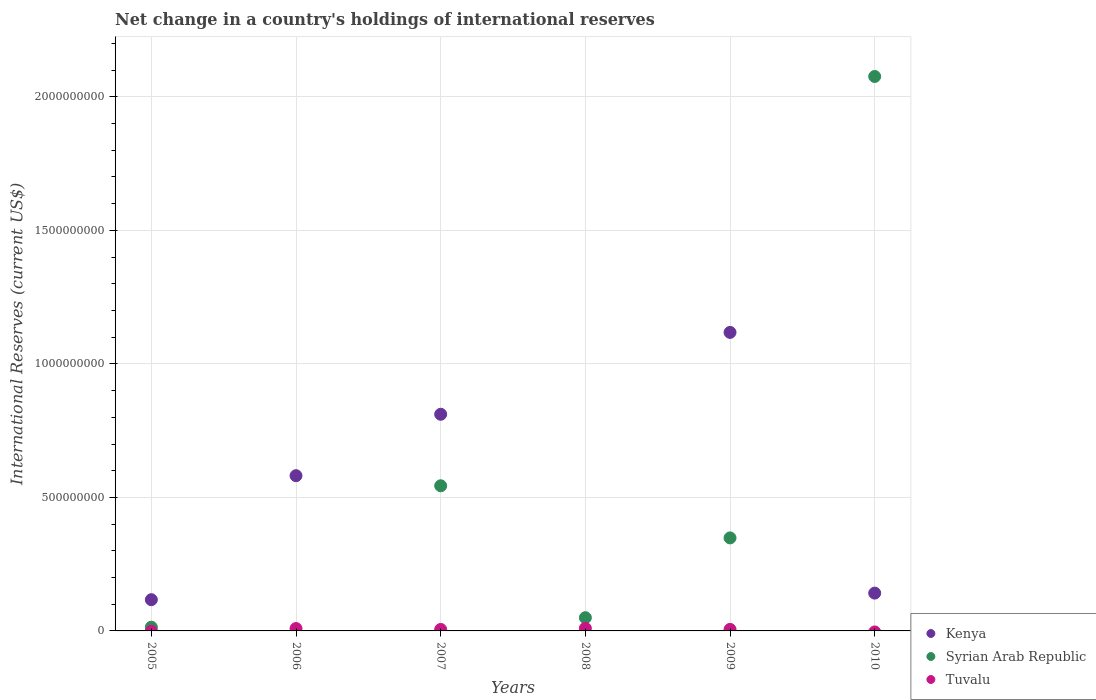Is the number of dotlines equal to the number of legend labels?
Provide a succinct answer. No. What is the international reserves in Syrian Arab Republic in 2010?
Keep it short and to the point. 2.08e+09. Across all years, what is the maximum international reserves in Kenya?
Make the answer very short. 1.12e+09. Across all years, what is the minimum international reserves in Syrian Arab Republic?
Your answer should be compact. 0. In which year was the international reserves in Kenya maximum?
Your answer should be compact. 2009. What is the total international reserves in Tuvalu in the graph?
Your response must be concise. 3.00e+07. What is the difference between the international reserves in Syrian Arab Republic in 2007 and that in 2009?
Offer a terse response. 1.95e+08. What is the difference between the international reserves in Syrian Arab Republic in 2005 and the international reserves in Kenya in 2009?
Provide a short and direct response. -1.10e+09. What is the average international reserves in Tuvalu per year?
Give a very brief answer. 5.00e+06. In the year 2005, what is the difference between the international reserves in Kenya and international reserves in Syrian Arab Republic?
Offer a terse response. 1.03e+08. What is the ratio of the international reserves in Kenya in 2009 to that in 2010?
Make the answer very short. 7.9. What is the difference between the highest and the second highest international reserves in Kenya?
Give a very brief answer. 3.07e+08. What is the difference between the highest and the lowest international reserves in Syrian Arab Republic?
Provide a short and direct response. 2.08e+09. In how many years, is the international reserves in Syrian Arab Republic greater than the average international reserves in Syrian Arab Republic taken over all years?
Keep it short and to the point. 2. Does the international reserves in Tuvalu monotonically increase over the years?
Provide a short and direct response. No. Is the international reserves in Syrian Arab Republic strictly less than the international reserves in Kenya over the years?
Offer a very short reply. No. Are the values on the major ticks of Y-axis written in scientific E-notation?
Provide a short and direct response. No. Does the graph contain any zero values?
Give a very brief answer. Yes. Does the graph contain grids?
Provide a short and direct response. Yes. Where does the legend appear in the graph?
Offer a very short reply. Bottom right. How are the legend labels stacked?
Provide a succinct answer. Vertical. What is the title of the graph?
Provide a succinct answer. Net change in a country's holdings of international reserves. What is the label or title of the X-axis?
Give a very brief answer. Years. What is the label or title of the Y-axis?
Provide a short and direct response. International Reserves (current US$). What is the International Reserves (current US$) in Kenya in 2005?
Your answer should be compact. 1.17e+08. What is the International Reserves (current US$) in Syrian Arab Republic in 2005?
Your answer should be very brief. 1.40e+07. What is the International Reserves (current US$) in Tuvalu in 2005?
Provide a succinct answer. 0. What is the International Reserves (current US$) of Kenya in 2006?
Offer a very short reply. 5.81e+08. What is the International Reserves (current US$) in Syrian Arab Republic in 2006?
Provide a succinct answer. 0. What is the International Reserves (current US$) of Tuvalu in 2006?
Your response must be concise. 8.93e+06. What is the International Reserves (current US$) in Kenya in 2007?
Your answer should be compact. 8.11e+08. What is the International Reserves (current US$) of Syrian Arab Republic in 2007?
Provide a succinct answer. 5.44e+08. What is the International Reserves (current US$) in Tuvalu in 2007?
Ensure brevity in your answer.  5.58e+06. What is the International Reserves (current US$) in Kenya in 2008?
Provide a short and direct response. 0. What is the International Reserves (current US$) of Syrian Arab Republic in 2008?
Provide a succinct answer. 4.96e+07. What is the International Reserves (current US$) in Tuvalu in 2008?
Provide a short and direct response. 9.75e+06. What is the International Reserves (current US$) of Kenya in 2009?
Give a very brief answer. 1.12e+09. What is the International Reserves (current US$) in Syrian Arab Republic in 2009?
Your response must be concise. 3.48e+08. What is the International Reserves (current US$) of Tuvalu in 2009?
Ensure brevity in your answer.  5.74e+06. What is the International Reserves (current US$) in Kenya in 2010?
Your answer should be compact. 1.42e+08. What is the International Reserves (current US$) in Syrian Arab Republic in 2010?
Offer a very short reply. 2.08e+09. Across all years, what is the maximum International Reserves (current US$) in Kenya?
Offer a very short reply. 1.12e+09. Across all years, what is the maximum International Reserves (current US$) of Syrian Arab Republic?
Provide a short and direct response. 2.08e+09. Across all years, what is the maximum International Reserves (current US$) of Tuvalu?
Your answer should be very brief. 9.75e+06. Across all years, what is the minimum International Reserves (current US$) of Syrian Arab Republic?
Ensure brevity in your answer.  0. Across all years, what is the minimum International Reserves (current US$) in Tuvalu?
Your answer should be compact. 0. What is the total International Reserves (current US$) of Kenya in the graph?
Offer a terse response. 2.77e+09. What is the total International Reserves (current US$) in Syrian Arab Republic in the graph?
Ensure brevity in your answer.  3.03e+09. What is the total International Reserves (current US$) in Tuvalu in the graph?
Provide a short and direct response. 3.00e+07. What is the difference between the International Reserves (current US$) in Kenya in 2005 and that in 2006?
Provide a short and direct response. -4.64e+08. What is the difference between the International Reserves (current US$) in Kenya in 2005 and that in 2007?
Make the answer very short. -6.94e+08. What is the difference between the International Reserves (current US$) of Syrian Arab Republic in 2005 and that in 2007?
Make the answer very short. -5.30e+08. What is the difference between the International Reserves (current US$) of Syrian Arab Republic in 2005 and that in 2008?
Make the answer very short. -3.56e+07. What is the difference between the International Reserves (current US$) in Kenya in 2005 and that in 2009?
Keep it short and to the point. -1.00e+09. What is the difference between the International Reserves (current US$) in Syrian Arab Republic in 2005 and that in 2009?
Provide a short and direct response. -3.34e+08. What is the difference between the International Reserves (current US$) in Kenya in 2005 and that in 2010?
Your answer should be compact. -2.46e+07. What is the difference between the International Reserves (current US$) in Syrian Arab Republic in 2005 and that in 2010?
Provide a short and direct response. -2.06e+09. What is the difference between the International Reserves (current US$) in Kenya in 2006 and that in 2007?
Give a very brief answer. -2.30e+08. What is the difference between the International Reserves (current US$) in Tuvalu in 2006 and that in 2007?
Provide a succinct answer. 3.34e+06. What is the difference between the International Reserves (current US$) of Tuvalu in 2006 and that in 2008?
Your answer should be compact. -8.27e+05. What is the difference between the International Reserves (current US$) of Kenya in 2006 and that in 2009?
Your response must be concise. -5.37e+08. What is the difference between the International Reserves (current US$) in Tuvalu in 2006 and that in 2009?
Make the answer very short. 3.19e+06. What is the difference between the International Reserves (current US$) in Kenya in 2006 and that in 2010?
Provide a short and direct response. 4.40e+08. What is the difference between the International Reserves (current US$) of Syrian Arab Republic in 2007 and that in 2008?
Your answer should be compact. 4.94e+08. What is the difference between the International Reserves (current US$) of Tuvalu in 2007 and that in 2008?
Offer a terse response. -4.17e+06. What is the difference between the International Reserves (current US$) of Kenya in 2007 and that in 2009?
Provide a short and direct response. -3.07e+08. What is the difference between the International Reserves (current US$) in Syrian Arab Republic in 2007 and that in 2009?
Your answer should be compact. 1.95e+08. What is the difference between the International Reserves (current US$) in Tuvalu in 2007 and that in 2009?
Offer a very short reply. -1.52e+05. What is the difference between the International Reserves (current US$) in Kenya in 2007 and that in 2010?
Provide a short and direct response. 6.70e+08. What is the difference between the International Reserves (current US$) of Syrian Arab Republic in 2007 and that in 2010?
Provide a succinct answer. -1.53e+09. What is the difference between the International Reserves (current US$) of Syrian Arab Republic in 2008 and that in 2009?
Offer a very short reply. -2.99e+08. What is the difference between the International Reserves (current US$) in Tuvalu in 2008 and that in 2009?
Offer a terse response. 4.02e+06. What is the difference between the International Reserves (current US$) of Syrian Arab Republic in 2008 and that in 2010?
Provide a short and direct response. -2.03e+09. What is the difference between the International Reserves (current US$) of Kenya in 2009 and that in 2010?
Offer a terse response. 9.76e+08. What is the difference between the International Reserves (current US$) of Syrian Arab Republic in 2009 and that in 2010?
Offer a very short reply. -1.73e+09. What is the difference between the International Reserves (current US$) in Kenya in 2005 and the International Reserves (current US$) in Tuvalu in 2006?
Offer a very short reply. 1.08e+08. What is the difference between the International Reserves (current US$) of Syrian Arab Republic in 2005 and the International Reserves (current US$) of Tuvalu in 2006?
Give a very brief answer. 5.07e+06. What is the difference between the International Reserves (current US$) of Kenya in 2005 and the International Reserves (current US$) of Syrian Arab Republic in 2007?
Make the answer very short. -4.27e+08. What is the difference between the International Reserves (current US$) in Kenya in 2005 and the International Reserves (current US$) in Tuvalu in 2007?
Ensure brevity in your answer.  1.11e+08. What is the difference between the International Reserves (current US$) of Syrian Arab Republic in 2005 and the International Reserves (current US$) of Tuvalu in 2007?
Offer a terse response. 8.41e+06. What is the difference between the International Reserves (current US$) of Kenya in 2005 and the International Reserves (current US$) of Syrian Arab Republic in 2008?
Your answer should be very brief. 6.74e+07. What is the difference between the International Reserves (current US$) in Kenya in 2005 and the International Reserves (current US$) in Tuvalu in 2008?
Offer a very short reply. 1.07e+08. What is the difference between the International Reserves (current US$) in Syrian Arab Republic in 2005 and the International Reserves (current US$) in Tuvalu in 2008?
Provide a short and direct response. 4.24e+06. What is the difference between the International Reserves (current US$) in Kenya in 2005 and the International Reserves (current US$) in Syrian Arab Republic in 2009?
Your answer should be very brief. -2.31e+08. What is the difference between the International Reserves (current US$) of Kenya in 2005 and the International Reserves (current US$) of Tuvalu in 2009?
Your answer should be compact. 1.11e+08. What is the difference between the International Reserves (current US$) of Syrian Arab Republic in 2005 and the International Reserves (current US$) of Tuvalu in 2009?
Provide a short and direct response. 8.26e+06. What is the difference between the International Reserves (current US$) of Kenya in 2005 and the International Reserves (current US$) of Syrian Arab Republic in 2010?
Give a very brief answer. -1.96e+09. What is the difference between the International Reserves (current US$) in Kenya in 2006 and the International Reserves (current US$) in Syrian Arab Republic in 2007?
Ensure brevity in your answer.  3.78e+07. What is the difference between the International Reserves (current US$) in Kenya in 2006 and the International Reserves (current US$) in Tuvalu in 2007?
Make the answer very short. 5.76e+08. What is the difference between the International Reserves (current US$) in Kenya in 2006 and the International Reserves (current US$) in Syrian Arab Republic in 2008?
Your answer should be compact. 5.32e+08. What is the difference between the International Reserves (current US$) of Kenya in 2006 and the International Reserves (current US$) of Tuvalu in 2008?
Offer a terse response. 5.72e+08. What is the difference between the International Reserves (current US$) in Kenya in 2006 and the International Reserves (current US$) in Syrian Arab Republic in 2009?
Make the answer very short. 2.33e+08. What is the difference between the International Reserves (current US$) of Kenya in 2006 and the International Reserves (current US$) of Tuvalu in 2009?
Keep it short and to the point. 5.76e+08. What is the difference between the International Reserves (current US$) in Kenya in 2006 and the International Reserves (current US$) in Syrian Arab Republic in 2010?
Provide a succinct answer. -1.50e+09. What is the difference between the International Reserves (current US$) of Kenya in 2007 and the International Reserves (current US$) of Syrian Arab Republic in 2008?
Offer a terse response. 7.62e+08. What is the difference between the International Reserves (current US$) of Kenya in 2007 and the International Reserves (current US$) of Tuvalu in 2008?
Provide a succinct answer. 8.02e+08. What is the difference between the International Reserves (current US$) of Syrian Arab Republic in 2007 and the International Reserves (current US$) of Tuvalu in 2008?
Your answer should be very brief. 5.34e+08. What is the difference between the International Reserves (current US$) in Kenya in 2007 and the International Reserves (current US$) in Syrian Arab Republic in 2009?
Ensure brevity in your answer.  4.63e+08. What is the difference between the International Reserves (current US$) of Kenya in 2007 and the International Reserves (current US$) of Tuvalu in 2009?
Offer a terse response. 8.06e+08. What is the difference between the International Reserves (current US$) in Syrian Arab Republic in 2007 and the International Reserves (current US$) in Tuvalu in 2009?
Provide a short and direct response. 5.38e+08. What is the difference between the International Reserves (current US$) of Kenya in 2007 and the International Reserves (current US$) of Syrian Arab Republic in 2010?
Your answer should be very brief. -1.27e+09. What is the difference between the International Reserves (current US$) of Syrian Arab Republic in 2008 and the International Reserves (current US$) of Tuvalu in 2009?
Give a very brief answer. 4.38e+07. What is the difference between the International Reserves (current US$) in Kenya in 2009 and the International Reserves (current US$) in Syrian Arab Republic in 2010?
Give a very brief answer. -9.58e+08. What is the average International Reserves (current US$) in Kenya per year?
Keep it short and to the point. 4.62e+08. What is the average International Reserves (current US$) of Syrian Arab Republic per year?
Provide a succinct answer. 5.05e+08. What is the average International Reserves (current US$) in Tuvalu per year?
Give a very brief answer. 5.00e+06. In the year 2005, what is the difference between the International Reserves (current US$) in Kenya and International Reserves (current US$) in Syrian Arab Republic?
Keep it short and to the point. 1.03e+08. In the year 2006, what is the difference between the International Reserves (current US$) in Kenya and International Reserves (current US$) in Tuvalu?
Provide a succinct answer. 5.72e+08. In the year 2007, what is the difference between the International Reserves (current US$) in Kenya and International Reserves (current US$) in Syrian Arab Republic?
Provide a short and direct response. 2.68e+08. In the year 2007, what is the difference between the International Reserves (current US$) in Kenya and International Reserves (current US$) in Tuvalu?
Your answer should be very brief. 8.06e+08. In the year 2007, what is the difference between the International Reserves (current US$) in Syrian Arab Republic and International Reserves (current US$) in Tuvalu?
Ensure brevity in your answer.  5.38e+08. In the year 2008, what is the difference between the International Reserves (current US$) in Syrian Arab Republic and International Reserves (current US$) in Tuvalu?
Provide a succinct answer. 3.98e+07. In the year 2009, what is the difference between the International Reserves (current US$) of Kenya and International Reserves (current US$) of Syrian Arab Republic?
Offer a very short reply. 7.70e+08. In the year 2009, what is the difference between the International Reserves (current US$) of Kenya and International Reserves (current US$) of Tuvalu?
Provide a short and direct response. 1.11e+09. In the year 2009, what is the difference between the International Reserves (current US$) of Syrian Arab Republic and International Reserves (current US$) of Tuvalu?
Ensure brevity in your answer.  3.43e+08. In the year 2010, what is the difference between the International Reserves (current US$) in Kenya and International Reserves (current US$) in Syrian Arab Republic?
Your answer should be very brief. -1.93e+09. What is the ratio of the International Reserves (current US$) of Kenya in 2005 to that in 2006?
Your answer should be very brief. 0.2. What is the ratio of the International Reserves (current US$) of Kenya in 2005 to that in 2007?
Make the answer very short. 0.14. What is the ratio of the International Reserves (current US$) in Syrian Arab Republic in 2005 to that in 2007?
Your response must be concise. 0.03. What is the ratio of the International Reserves (current US$) in Syrian Arab Republic in 2005 to that in 2008?
Give a very brief answer. 0.28. What is the ratio of the International Reserves (current US$) in Kenya in 2005 to that in 2009?
Make the answer very short. 0.1. What is the ratio of the International Reserves (current US$) of Syrian Arab Republic in 2005 to that in 2009?
Your answer should be compact. 0.04. What is the ratio of the International Reserves (current US$) in Kenya in 2005 to that in 2010?
Your answer should be very brief. 0.83. What is the ratio of the International Reserves (current US$) of Syrian Arab Republic in 2005 to that in 2010?
Make the answer very short. 0.01. What is the ratio of the International Reserves (current US$) of Kenya in 2006 to that in 2007?
Make the answer very short. 0.72. What is the ratio of the International Reserves (current US$) of Tuvalu in 2006 to that in 2007?
Your response must be concise. 1.6. What is the ratio of the International Reserves (current US$) in Tuvalu in 2006 to that in 2008?
Your answer should be very brief. 0.92. What is the ratio of the International Reserves (current US$) of Kenya in 2006 to that in 2009?
Your answer should be very brief. 0.52. What is the ratio of the International Reserves (current US$) of Tuvalu in 2006 to that in 2009?
Provide a short and direct response. 1.56. What is the ratio of the International Reserves (current US$) in Kenya in 2006 to that in 2010?
Provide a succinct answer. 4.11. What is the ratio of the International Reserves (current US$) in Syrian Arab Republic in 2007 to that in 2008?
Give a very brief answer. 10.97. What is the ratio of the International Reserves (current US$) of Tuvalu in 2007 to that in 2008?
Offer a terse response. 0.57. What is the ratio of the International Reserves (current US$) of Kenya in 2007 to that in 2009?
Provide a short and direct response. 0.73. What is the ratio of the International Reserves (current US$) in Syrian Arab Republic in 2007 to that in 2009?
Your response must be concise. 1.56. What is the ratio of the International Reserves (current US$) in Tuvalu in 2007 to that in 2009?
Provide a succinct answer. 0.97. What is the ratio of the International Reserves (current US$) of Kenya in 2007 to that in 2010?
Provide a short and direct response. 5.73. What is the ratio of the International Reserves (current US$) of Syrian Arab Republic in 2007 to that in 2010?
Offer a terse response. 0.26. What is the ratio of the International Reserves (current US$) of Syrian Arab Republic in 2008 to that in 2009?
Keep it short and to the point. 0.14. What is the ratio of the International Reserves (current US$) of Tuvalu in 2008 to that in 2009?
Provide a succinct answer. 1.7. What is the ratio of the International Reserves (current US$) in Syrian Arab Republic in 2008 to that in 2010?
Offer a terse response. 0.02. What is the ratio of the International Reserves (current US$) in Kenya in 2009 to that in 2010?
Offer a very short reply. 7.9. What is the ratio of the International Reserves (current US$) in Syrian Arab Republic in 2009 to that in 2010?
Your response must be concise. 0.17. What is the difference between the highest and the second highest International Reserves (current US$) in Kenya?
Provide a succinct answer. 3.07e+08. What is the difference between the highest and the second highest International Reserves (current US$) in Syrian Arab Republic?
Offer a terse response. 1.53e+09. What is the difference between the highest and the second highest International Reserves (current US$) in Tuvalu?
Your response must be concise. 8.27e+05. What is the difference between the highest and the lowest International Reserves (current US$) in Kenya?
Your answer should be very brief. 1.12e+09. What is the difference between the highest and the lowest International Reserves (current US$) of Syrian Arab Republic?
Give a very brief answer. 2.08e+09. What is the difference between the highest and the lowest International Reserves (current US$) of Tuvalu?
Ensure brevity in your answer.  9.75e+06. 